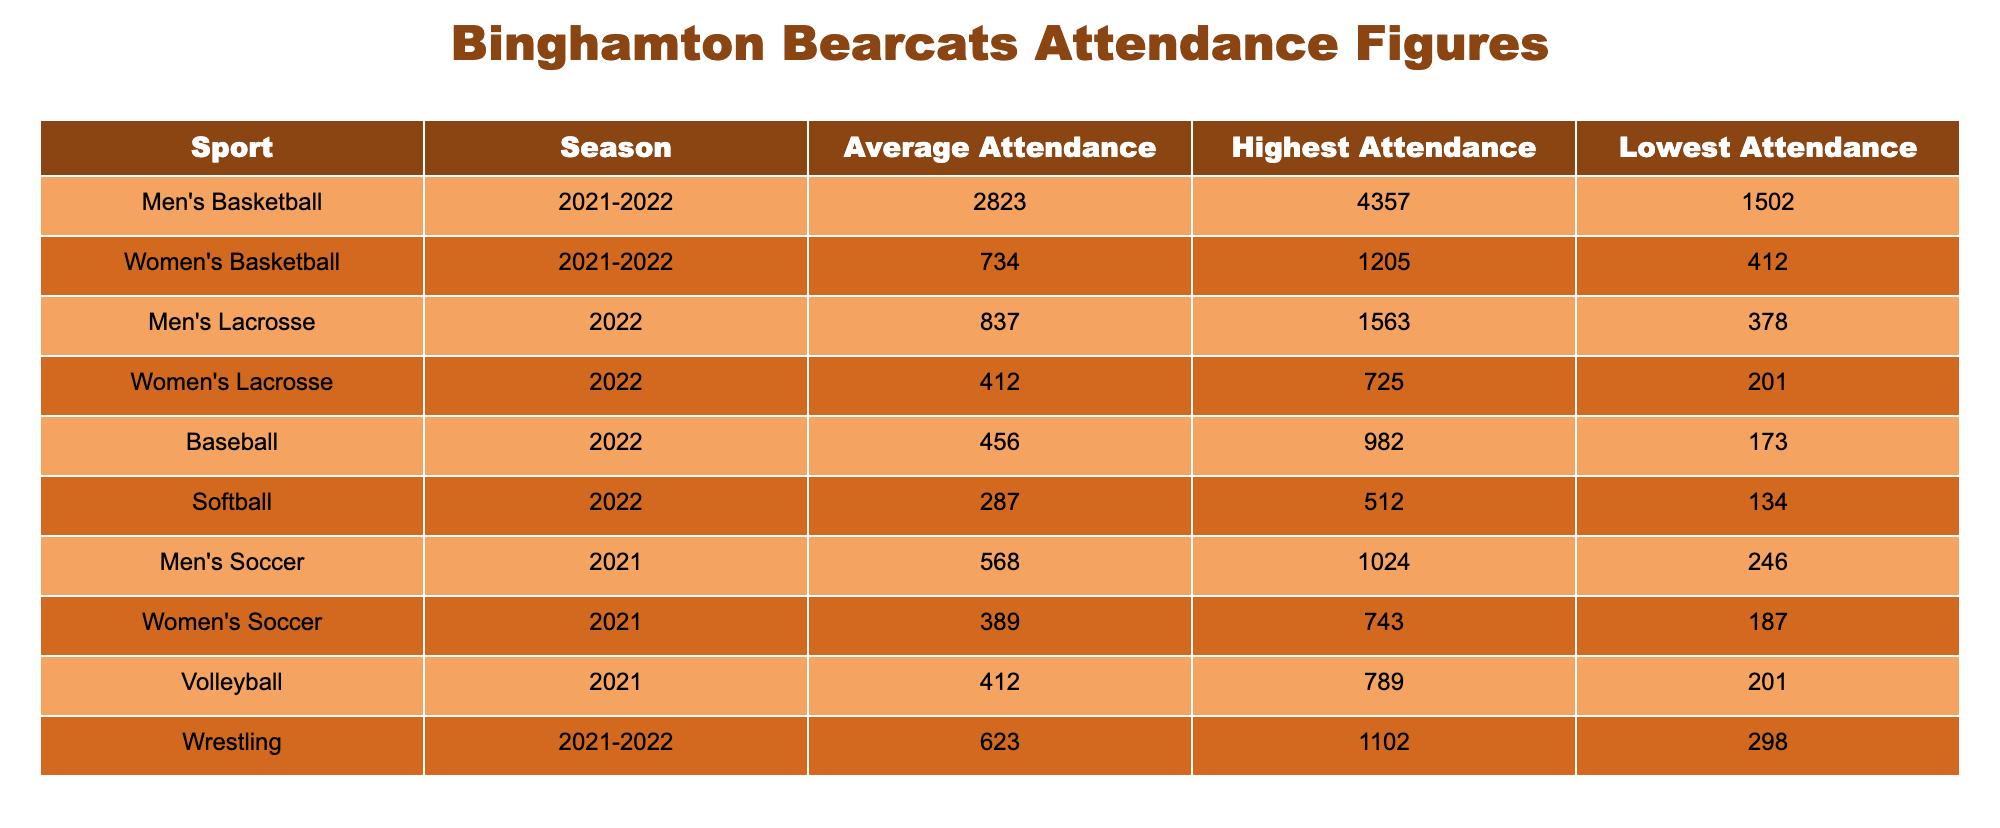What is the average attendance for Men's Basketball during the 2021-2022 season? The table shows the average attendance for Men's Basketball is listed as 2823 for the 2021-2022 season.
Answer: 2823 Which sport had the highest attendance and what was that figure? Referring to the table, Men's Basketball had the highest attendance recorded at 4357.
Answer: 4357 What is the difference between the highest and lowest attendance figures for Women's Basketball? The highest attendance for Women's Basketball is 1205 and the lowest is 412. The difference is 1205 - 412 = 793.
Answer: 793 Did Women's Soccer have an average attendance greater than 400? The average attendance for Women's Soccer is 389, which is less than 400, so the answer is no.
Answer: No Which sport had the lowest average attendance, and what was the figure? The table shows Softball had the lowest average attendance at 287.
Answer: 287 If you combine the average attendance figures for Men's and Women's Lacrosse, what is the total? The average attendance for Men's Lacrosse is 837 and for Women's Lacrosse is 412. The total is 837 + 412 = 1249.
Answer: 1249 What percentage of the highest attendance for Men's Soccer is the average attendance for that sport? The highest attendance for Men's Soccer is 1024 and the average is 568. To find the percentage, (568 / 1024) * 100 = 55.5%.
Answer: 55.5% Is the average attendance for Women’s Lacrosse higher than that of Women’s Soccer? The average for Women’s Lacrosse is 412 and for Women’s Soccer is 389. Since 412 is greater than 389, the answer is yes.
Answer: Yes What was the lowest recorded attendance figure across all sports in the table? The lowest attendance recorded in the table is for Softball at 134, as shown in the "Lowest Attendance" column.
Answer: 134 